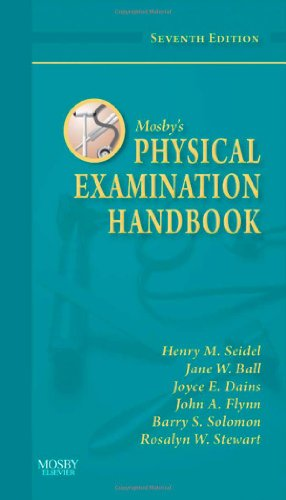What is the genre of this book? This book falls under the genre of Medical Books, specifically focusing on techniques and methods of physical examination in a healthcare setting. 